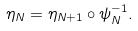Convert formula to latex. <formula><loc_0><loc_0><loc_500><loc_500>\eta _ { N } = \eta _ { N + 1 } \circ \psi _ { N } ^ { - 1 } .</formula> 